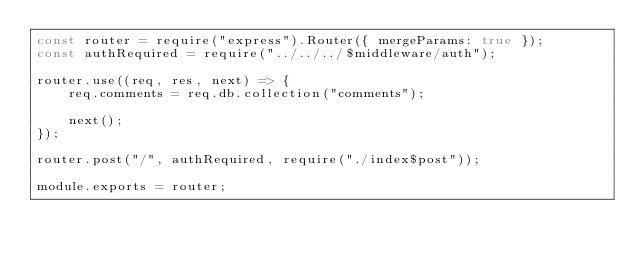Convert code to text. <code><loc_0><loc_0><loc_500><loc_500><_JavaScript_>const router = require("express").Router({ mergeParams: true });
const authRequired = require("../../../$middleware/auth");

router.use((req, res, next) => {
    req.comments = req.db.collection("comments");

    next();
});

router.post("/", authRequired, require("./index$post"));

module.exports = router;</code> 